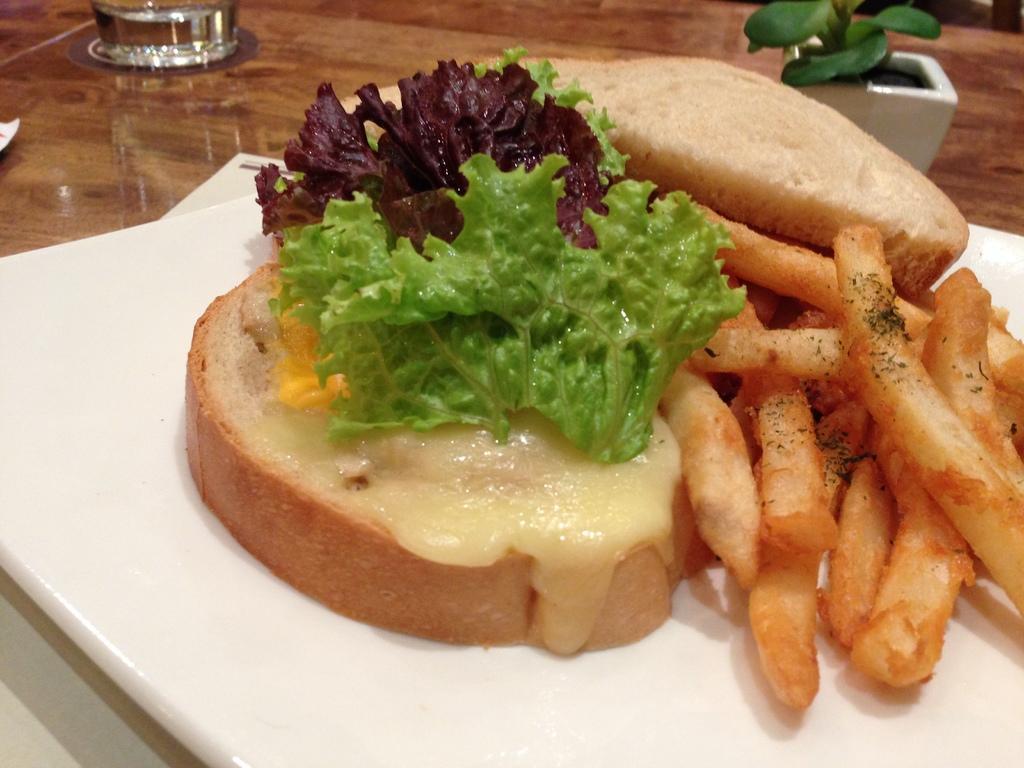How would you summarize this image in a sentence or two? There is a table. On the table there are glasses, pot with plant and a plate. On the plate there is a food item with leaves, french fries and some other thing. 